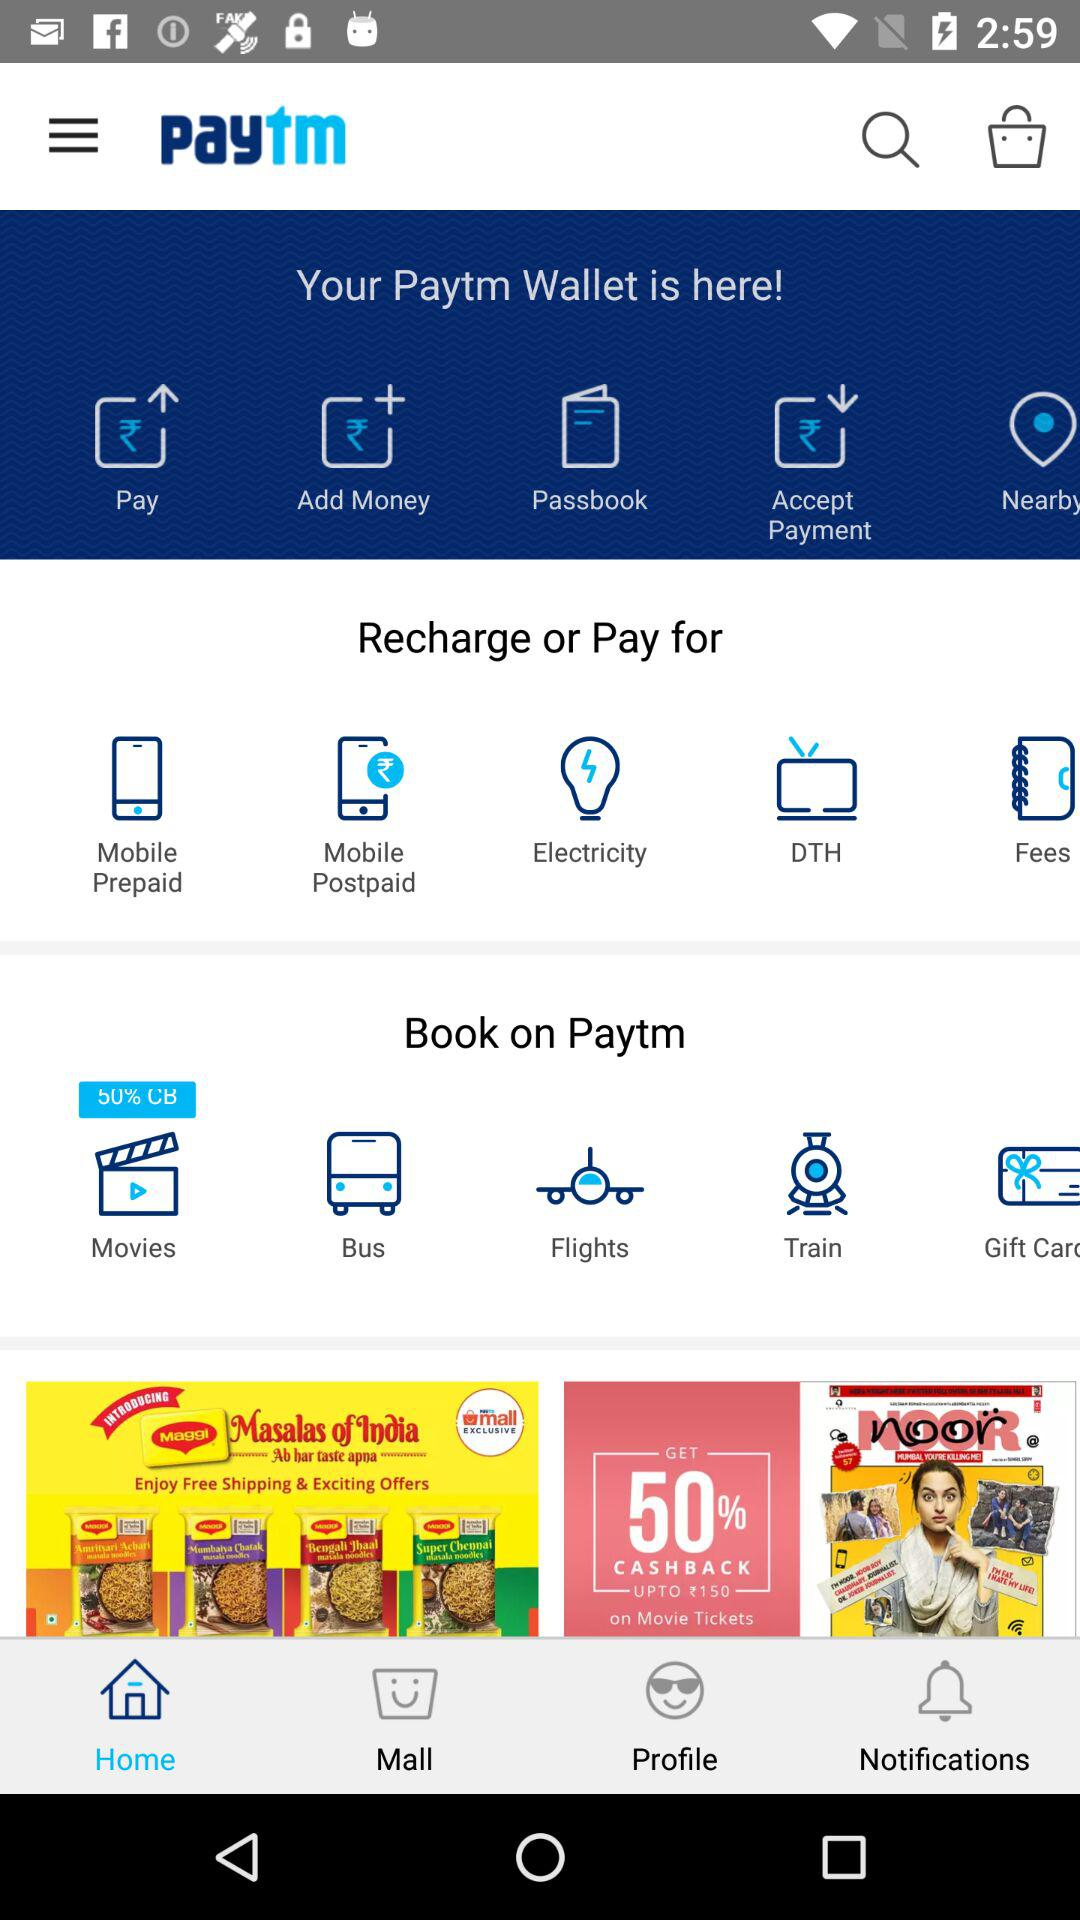What is the application name? The application name is "Paytm". 